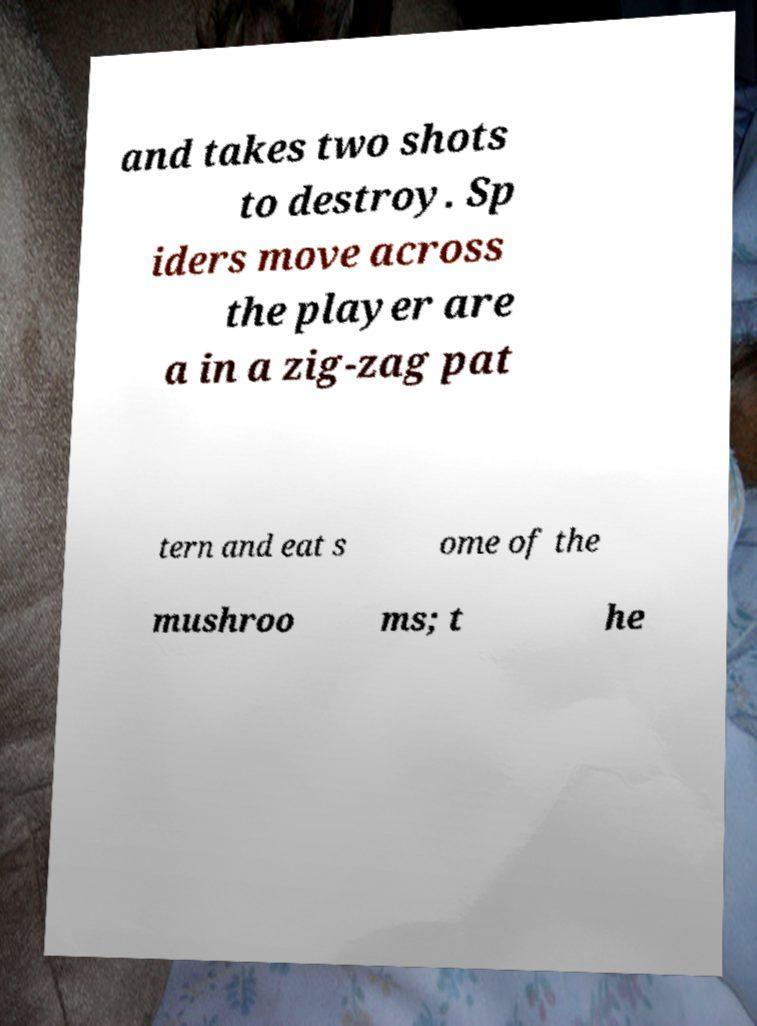There's text embedded in this image that I need extracted. Can you transcribe it verbatim? and takes two shots to destroy. Sp iders move across the player are a in a zig-zag pat tern and eat s ome of the mushroo ms; t he 